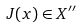Convert formula to latex. <formula><loc_0><loc_0><loc_500><loc_500>J ( x ) \in X ^ { \prime \prime }</formula> 